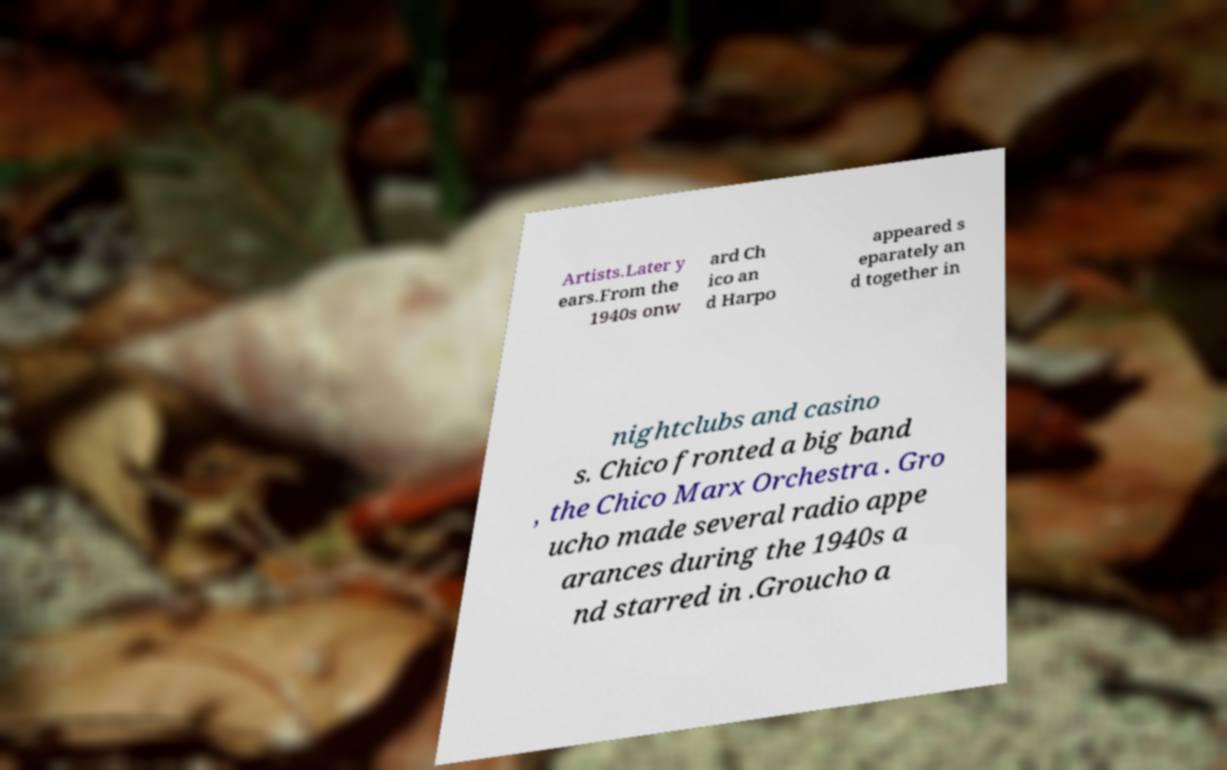Can you tell me more about the style of music Chico's orchestra played? While the details are not in the image, the Chico Marx Orchestra was known for playing popular music of the era, including swing and big band styles. These genres were characterized by their strong brass sections, rhythmic energy, and ability to get people dancing during the swing era. 